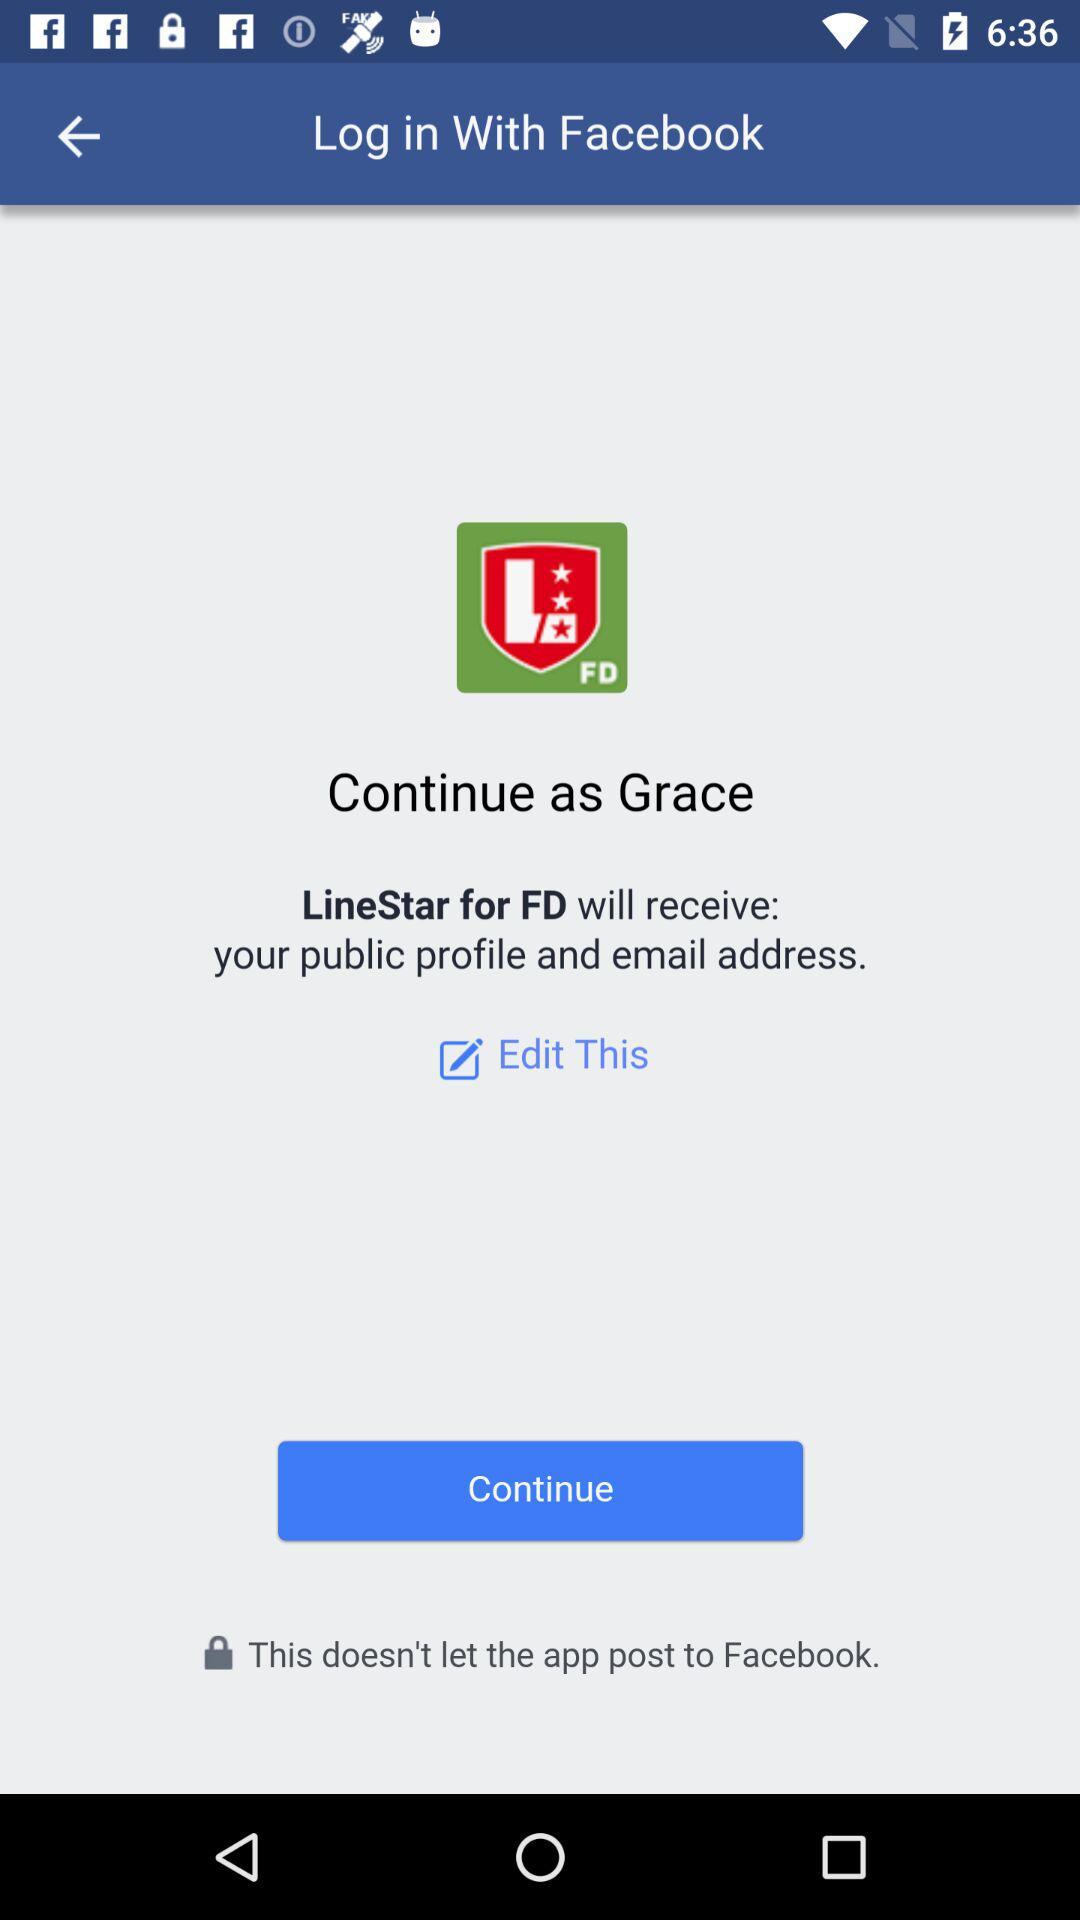What's the name of the user by whom the application can be continued? The name of the user is Grace. 